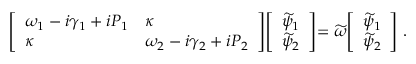Convert formula to latex. <formula><loc_0><loc_0><loc_500><loc_500>\left [ \begin{array} { l l } { \omega _ { 1 } - i \gamma _ { 1 } + i P _ { 1 } } & { \kappa } \\ { \kappa } & { \omega _ { 2 } - i \gamma _ { 2 } + i P _ { 2 } } \end{array} | d l e ] | d l e [ \begin{array} { l } { \widetilde { \psi } _ { 1 } } \\ { \widetilde { \psi } _ { 2 } } \end{array} | d l e ] = \widetilde { \omega } | d l e [ \begin{array} { l } { \widetilde { \psi } _ { 1 } } \\ { \widetilde { \psi } _ { 2 } } \end{array} \right ] \, .</formula> 